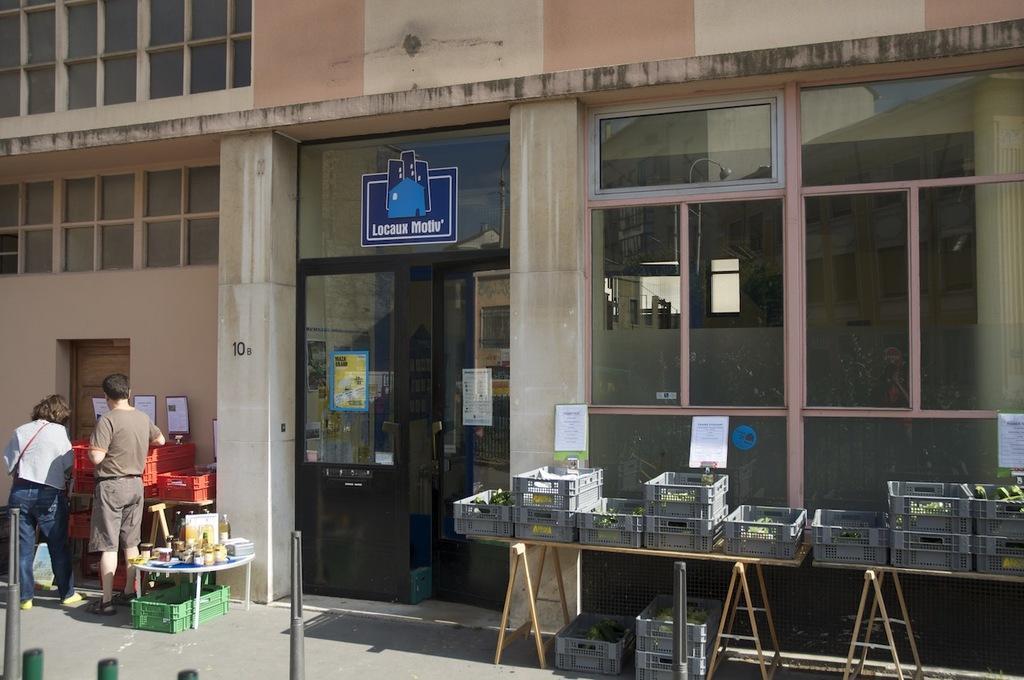Can you describe this image briefly? In this picture i could see two persons standing to the left side of the picture and some stuff in the baskets on the table and in the back ground i could see a glass door and a building. 